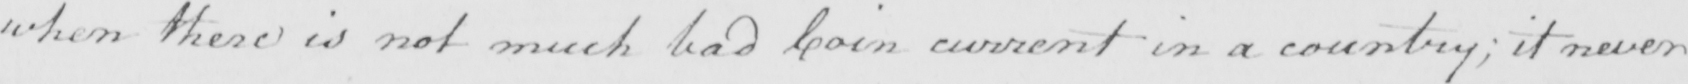Transcribe the text shown in this historical manuscript line. when there is not much bad Coin current in a country ; it never 